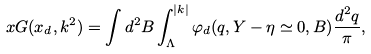<formula> <loc_0><loc_0><loc_500><loc_500>x G ( x _ { d } , { k } ^ { 2 } ) = \int d ^ { 2 } { B } \int _ { \Lambda } ^ { | { k } | } \varphi _ { d } ( { q } , Y - \eta \simeq 0 , { B } ) \frac { d ^ { 2 } { q } } { \pi } ,</formula> 